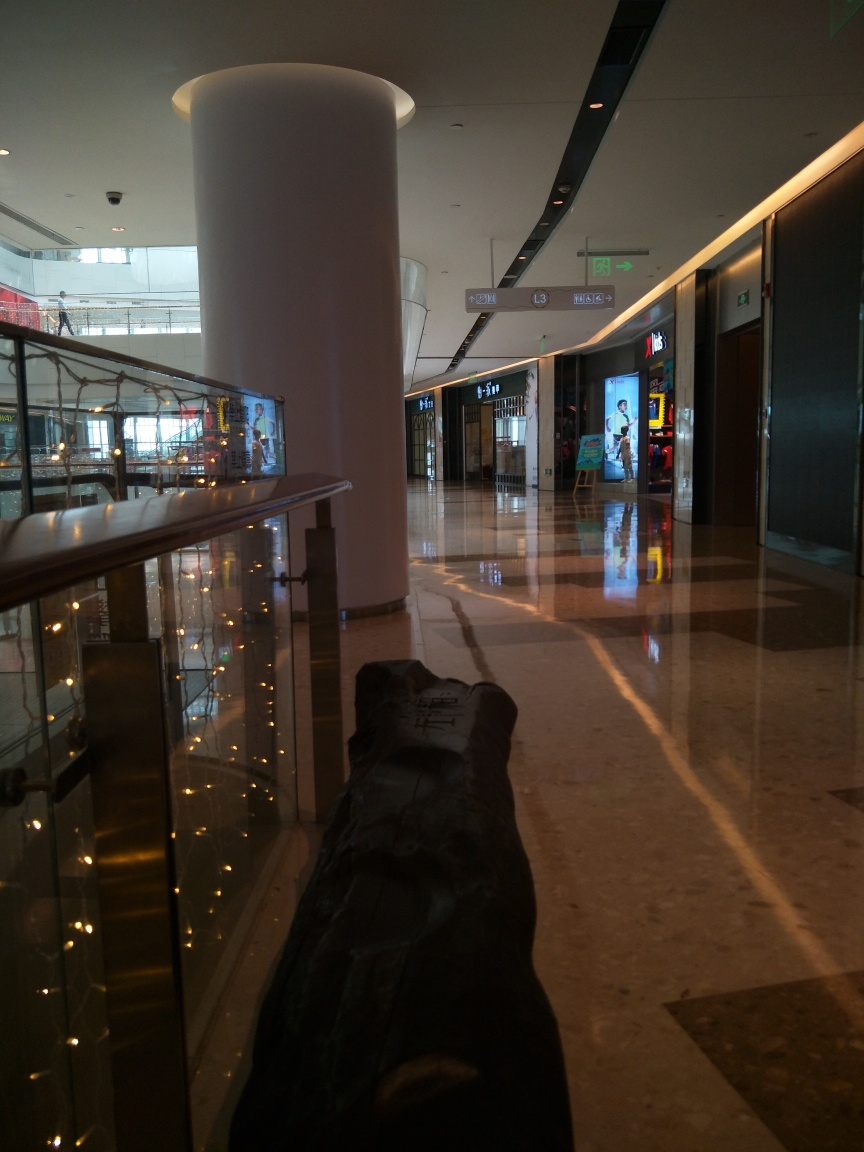What does the signage in the image suggest? There are some signs suspended from the ceiling, possibly indicating directions, store names, or floor levels; however, due to the image's perspective and quality, specific details on the signage are not clearly readable. 